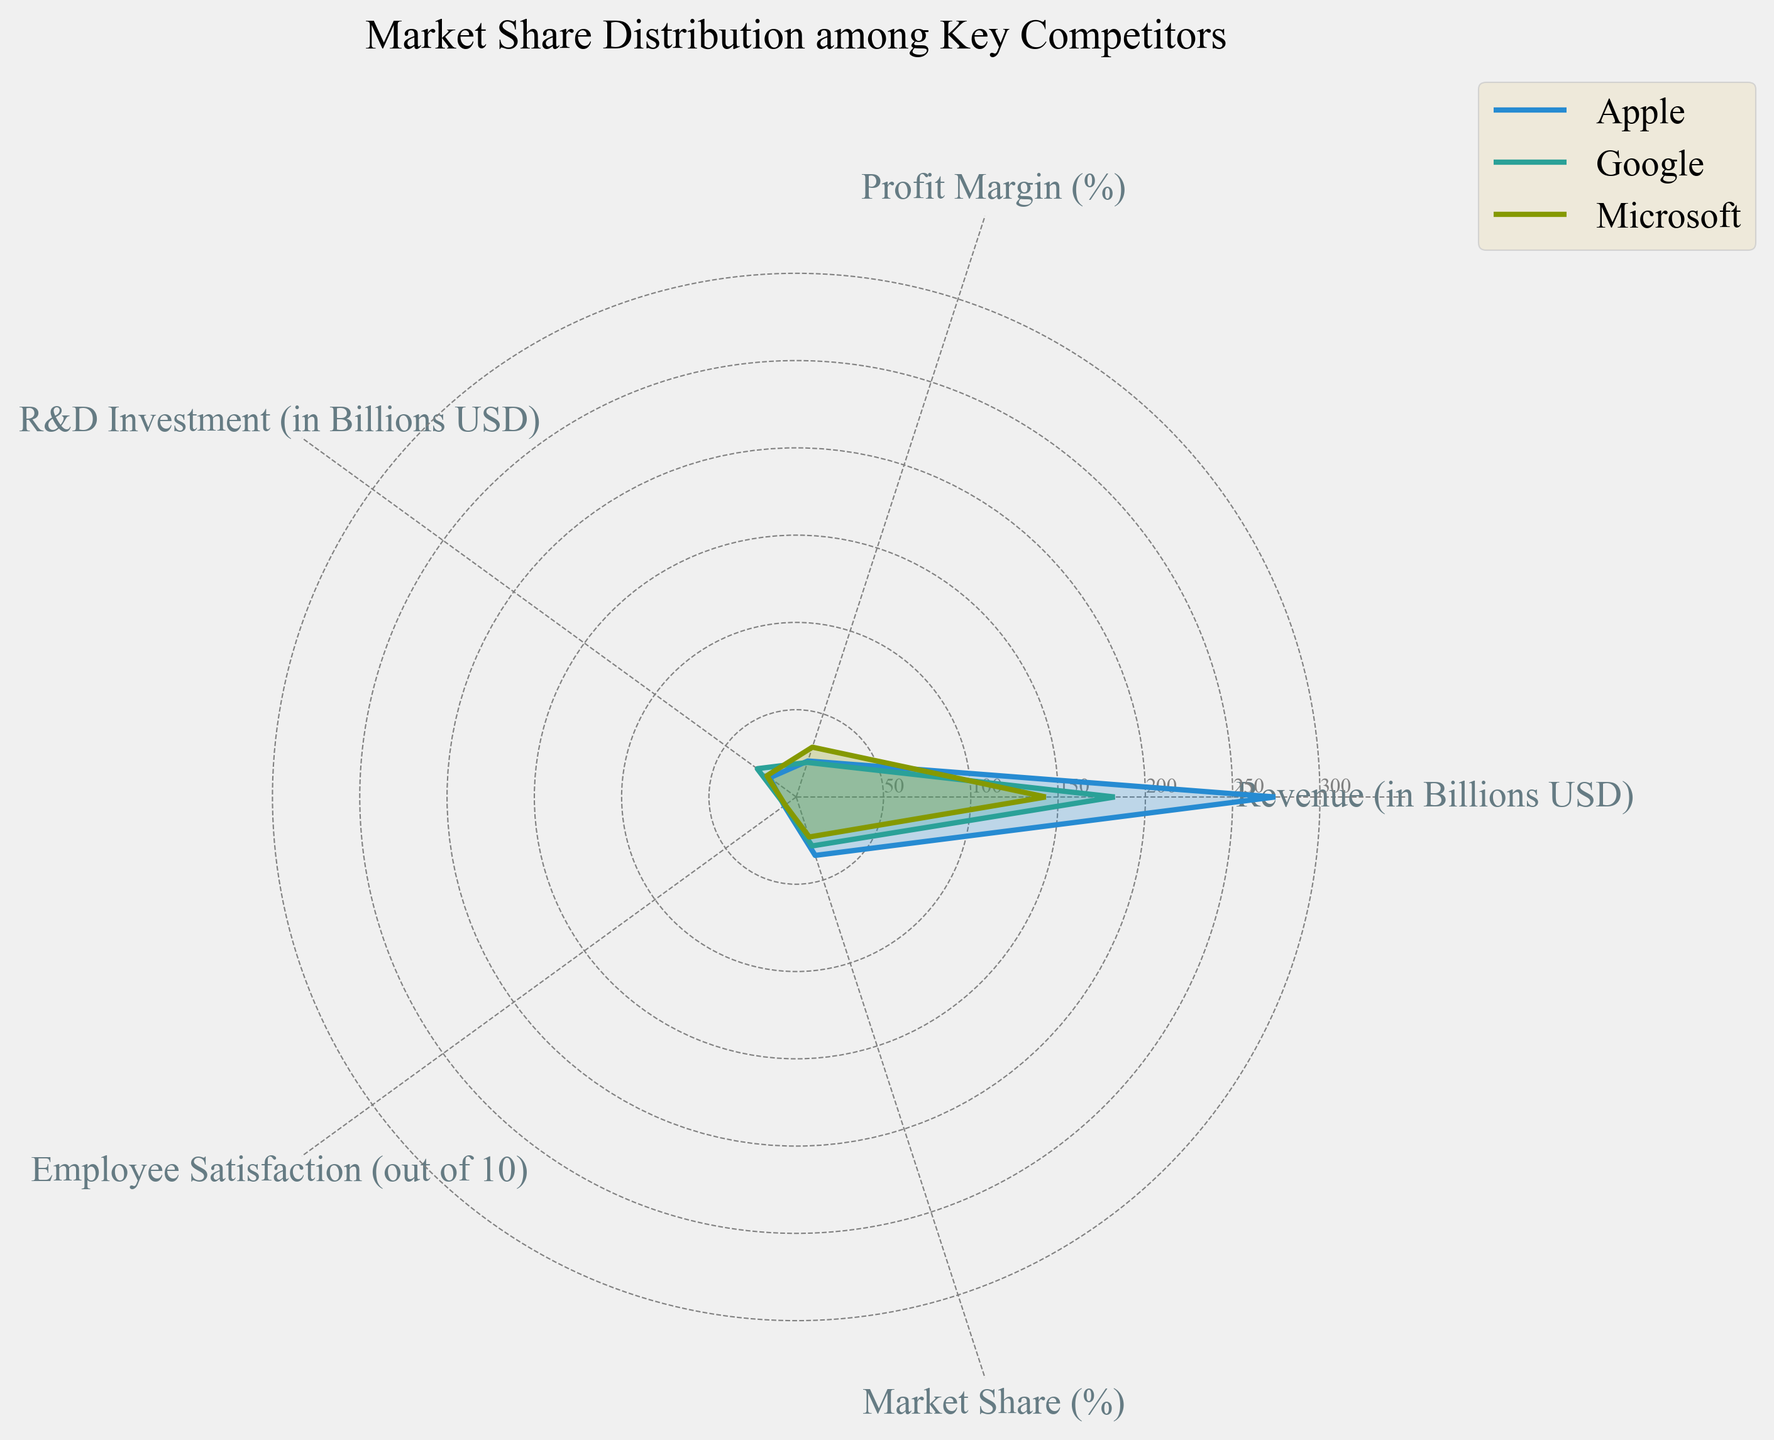what is the title of the radar chart? The title of a radar chart is typically found at the top of the figure. By reading the text above the radar plot, we see it is labelled "Market Share Distribution among Key Competitors".
Answer: Market Share Distribution among Key Competitors Which company has the highest Employee Satisfaction score? The Employee Satisfaction scores are one of the axes in the radar chart. By comparing the lengths of the respective axis for all companies, we can see that Apple has the highest Employee Satisfaction score of 8.5.
Answer: Apple Comparing the Profit Margin, which company fares better, Google or Microsoft? First, find the values of Profit Margin for both companies on the respective axis in the radar chart: Google has 20.8%, and Microsoft has 30.0%. Since 30.0% is greater than 20.8%, Microsoft fares better.
Answer: Microsoft What is the average R&D Investment of the companies shown? We need to find the R&D Investment for each company then calculate the average. The values are 18.75 (Apple), 27.57 (Google), 20.72 (Microsoft), and 42.74 (Amazon). Sum these values (18.75 + 27.57 + 20.72 + 42.74 = 109.78) and then divide by 4.
Answer: 27.45 Which company has the lowest Market Share? By comparing the Market Share axis values for each company, we see that Amazon, with 11.2%, has the lowest market share.
Answer: Amazon Do Apple and Google combined have a higher Market Share than Microsoft and Amazon combined? First calculate Apple's and Google's total Market Share (35.2 + 29.5 = 64.7). Then calculate Microsoft's and Amazon's combined Market Share (24.1 + 11.2 = 35.3). Since 64.7 > 35.3, yes, Apple and Google combined do have a higher Market Share.
Answer: Yes What is more influential for Amazon, R&D Investment or Profit Margin? To determine which is more influential for Amazon, we compare the radar chart's axes for R&D Investment (42.74B) and Profit Margin (10.3%). The significantly higher value of R&D Investment suggests it is more influential.
Answer: R&D Investment 